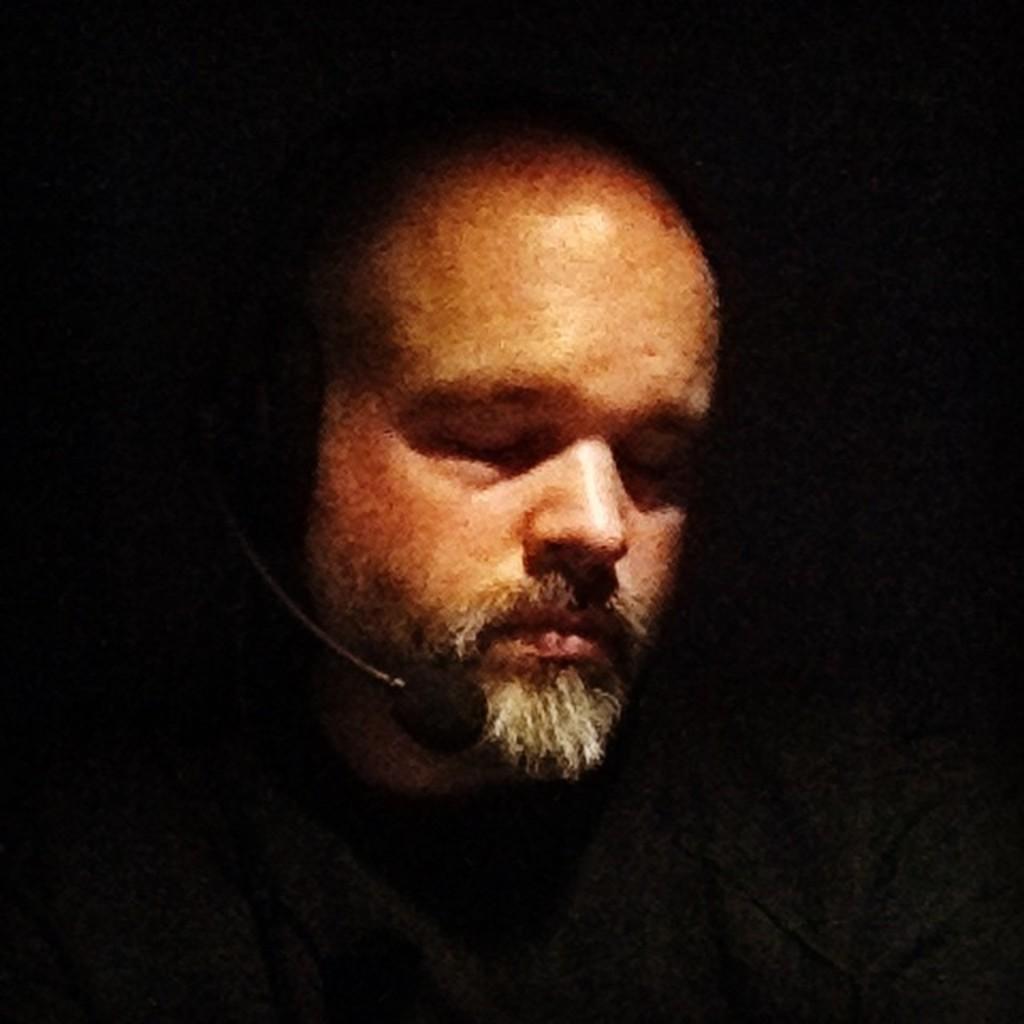Can you describe this image briefly? As we can see in the image there is a man and mini mic. 